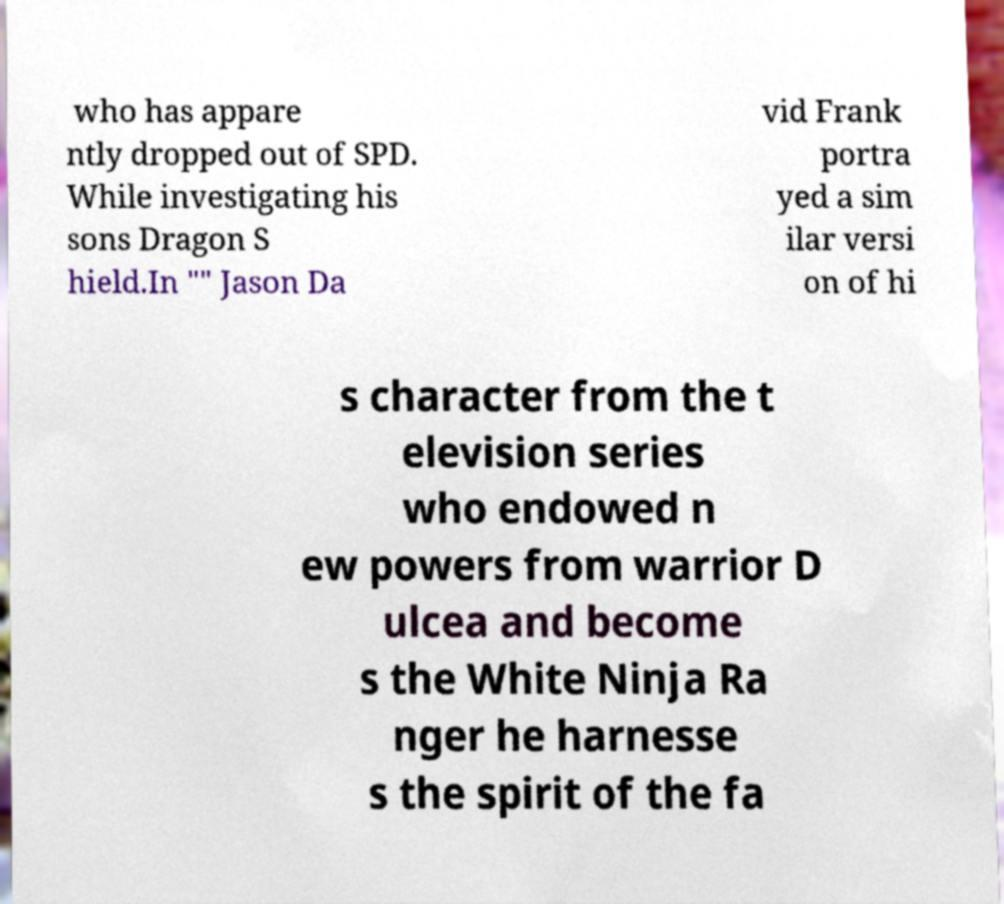Can you accurately transcribe the text from the provided image for me? who has appare ntly dropped out of SPD. While investigating his sons Dragon S hield.In "" Jason Da vid Frank portra yed a sim ilar versi on of hi s character from the t elevision series who endowed n ew powers from warrior D ulcea and become s the White Ninja Ra nger he harnesse s the spirit of the fa 